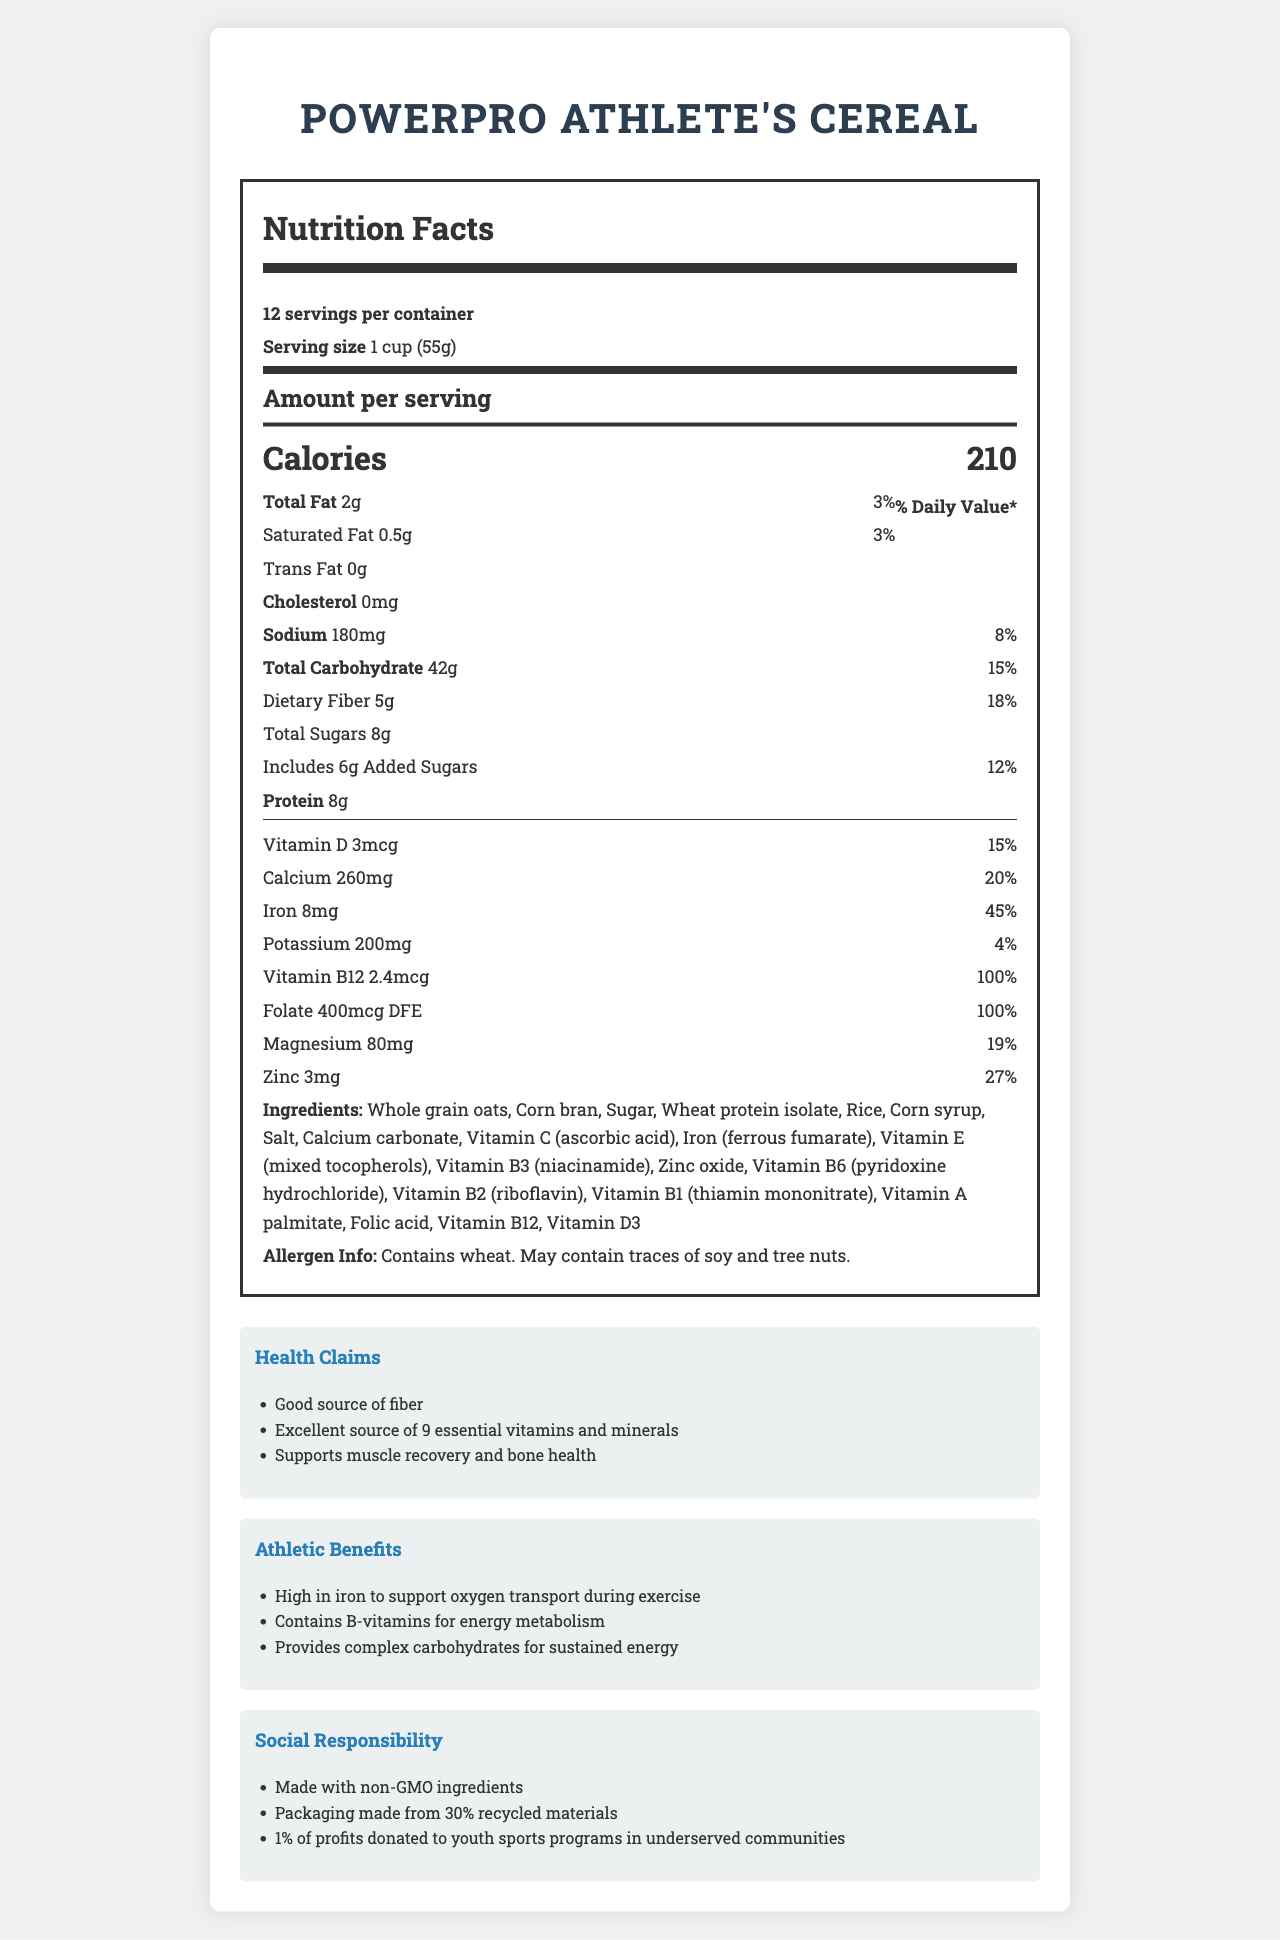what is the calorie content per serving? The "Calories" section lists 210 as the amount per serving.
Answer: 210 calories what percent of the daily value of calcium is in one serving? The "Calcium" section indicates that one serving provides 20% of the daily value.
Answer: 20% how much dietary fiber is in one serving? The "Dietary Fiber" section states that there are 5 grams of dietary fiber per serving.
Answer: 5g what are the ingredients of the cereal? The "Ingredients" section lists all the components included in the cereal.
Answer: Whole grain oats, Corn bran, Sugar, Wheat protein isolate, Rice, Corn syrup, Salt, Calcium carbonate, Vitamin C (ascorbic acid), Iron (ferrous fumarate), Vitamin E (mixed tocopherols), Vitamin B3 (niacinamide), Zinc oxide, Vitamin B6 (pyridoxine hydrochloride), Vitamin B2 (riboflavin), Vitamin B1 (thiamin mononitrate), Vitamin A palmitate, Folic acid, Vitamin B12, Vitamin D3 is wheat an allergen in this cereal? The "Allergen Info" section specifies that the cereal contains wheat.
Answer: Yes which vitamin provides 100% of the daily value per serving? A. Vitamin D B. Vitamin B12 C. Vitamin A D. Folate Both Vitamin B12 and Folate provide 100% of the daily value per serving as indicated in their respective sections.
Answer: B and D what is the sodium content of one serving, and what percentage of daily value does it represent? The "Sodium" section mentions that there are 180mg of sodium per serving, which is 8% of the daily value.
Answer: 180mg, 8% how many grams of protein does one serving of the cereal provide? The "Protein" section states that one serving contains 8 grams of protein.
Answer: 8g what health benefits are promoted by the cereal? A. Good source of fiber B. High in antioxidants C. Promotes weight loss D. Supports muscle recovery and bone health The "Health Claims" section lists "Good source of fiber" and "Supports muscle recovery and bone health", but not options B or C.
Answer: A and D true or false: The cereal contains only non-GMO ingredients. The "Social Responsibility" section states that the cereal is made with non-GMO ingredients.
Answer: True summarize the main features and benefits of the PowerPro Athlete's Cereal. The document describes a nutrient-rich cereal specially formulated for athletes, emphasizing its nutritional content, health benefits, athletic support, and social responsibility.
Answer: PowerPro Athlete's Cereal is a fortified breakfast cereal aiming to support student athletes with its high iron content, B-vitamins for energy metabolism, and complex carbohydrates for sustained energy. It contains essential vitamins and minerals, including 100% of the daily value for Vitamin B12 and Folate. Its ingredients are non-GMO, and it’s packaged using recycled materials. The cereal also contributes to social goals by donating a portion of profits to youth sports programs. how much Vitamin D is in one serving of the cereal? The "Vitamin D" section lists the amount as 3mcg per serving.
Answer: 3mcg what is the total carbohydrate content per serving and its percent daily value? The "Total Carbohydrate" section mentions that there are 42 grams per serving, which accounts for 15% of the daily value.
Answer: 42g, 15% can you determine the production date of this cereal from the document? The document does not provide details about the production date.
Answer: Not enough information 